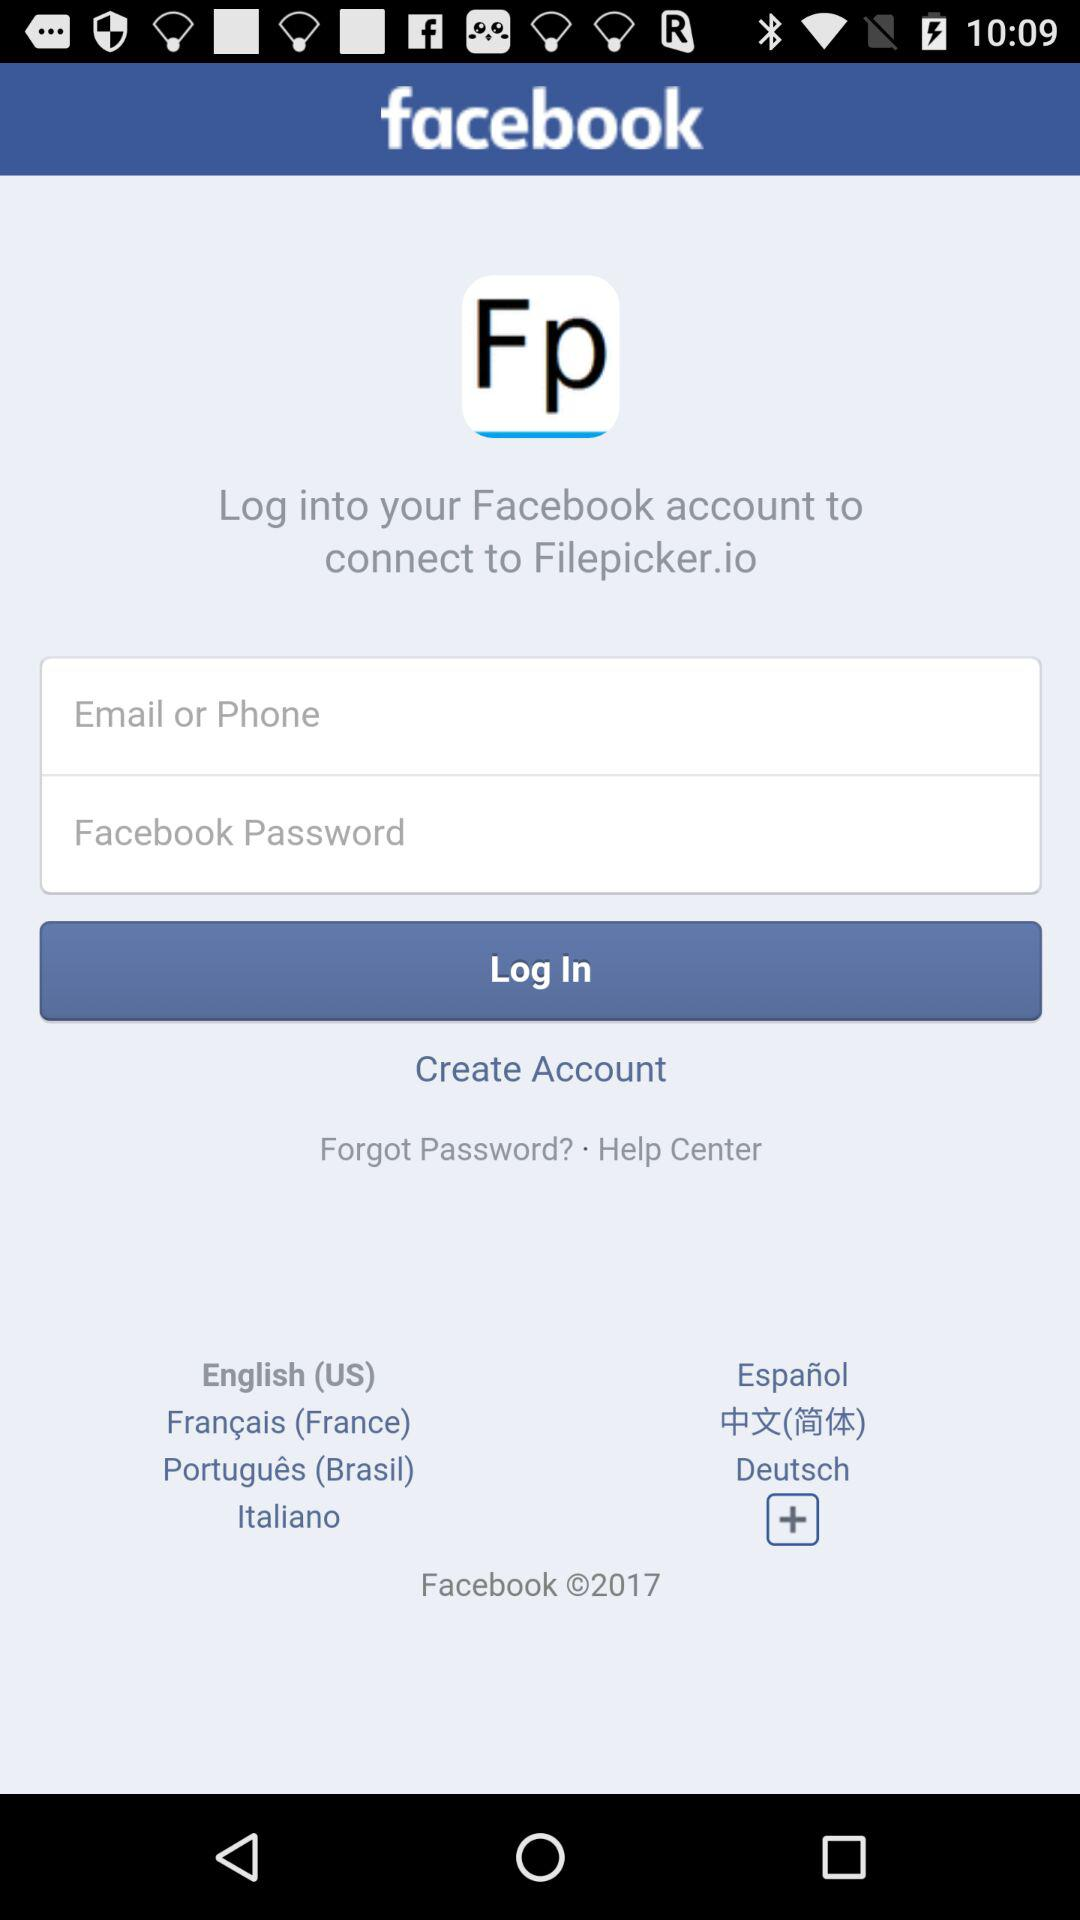How many languages are available for the user to choose from?
Answer the question using a single word or phrase. 7 